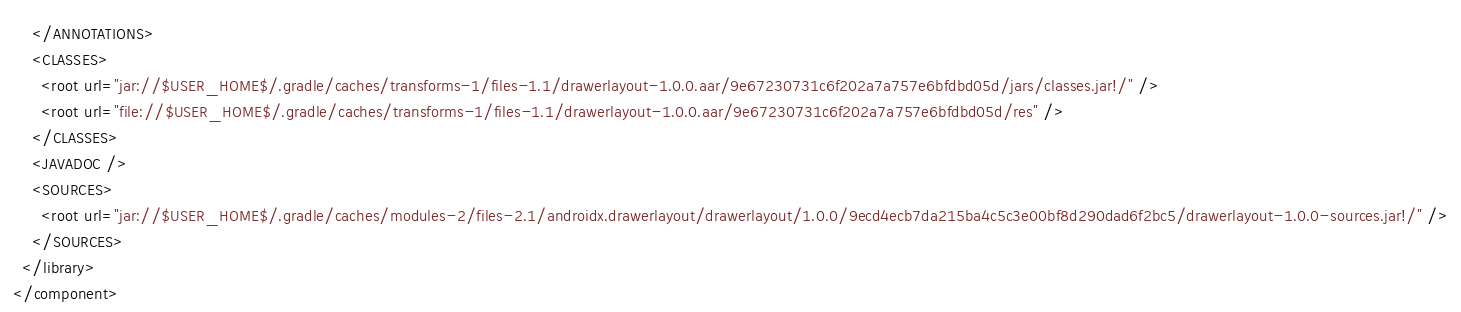<code> <loc_0><loc_0><loc_500><loc_500><_XML_>    </ANNOTATIONS>
    <CLASSES>
      <root url="jar://$USER_HOME$/.gradle/caches/transforms-1/files-1.1/drawerlayout-1.0.0.aar/9e67230731c6f202a7a757e6bfdbd05d/jars/classes.jar!/" />
      <root url="file://$USER_HOME$/.gradle/caches/transforms-1/files-1.1/drawerlayout-1.0.0.aar/9e67230731c6f202a7a757e6bfdbd05d/res" />
    </CLASSES>
    <JAVADOC />
    <SOURCES>
      <root url="jar://$USER_HOME$/.gradle/caches/modules-2/files-2.1/androidx.drawerlayout/drawerlayout/1.0.0/9ecd4ecb7da215ba4c5c3e00bf8d290dad6f2bc5/drawerlayout-1.0.0-sources.jar!/" />
    </SOURCES>
  </library>
</component></code> 